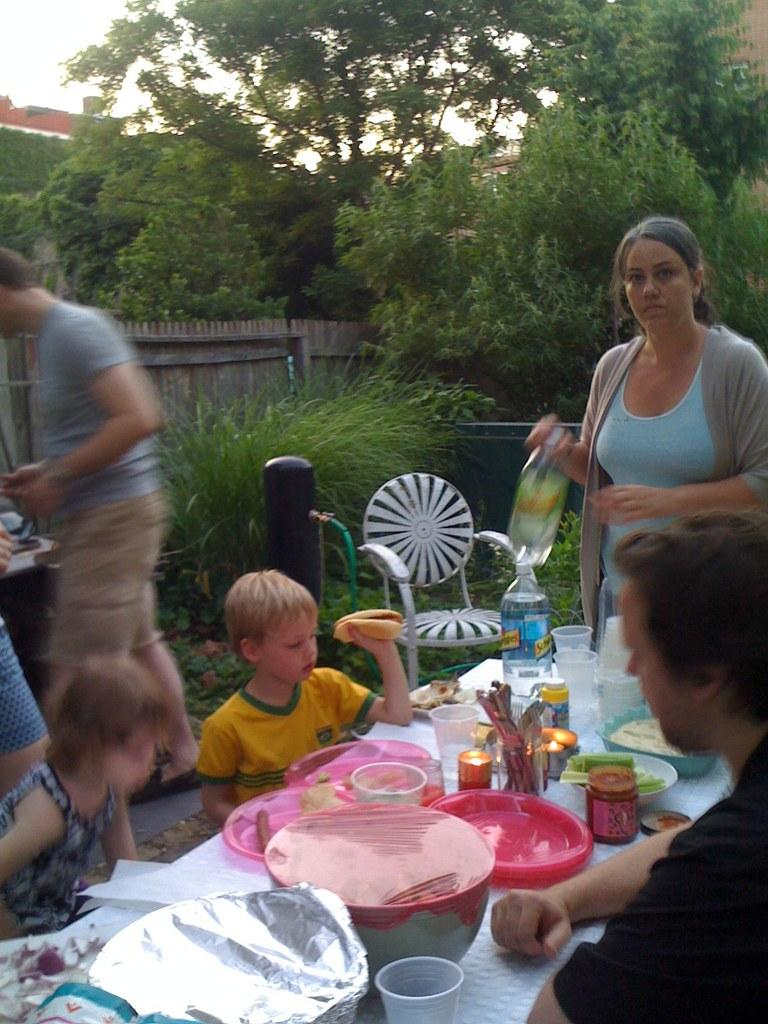What are the people in the image doing? There are people seated on chairs and some people standing in the image. What objects can be seen on the table? There are bowls, plates, bottles, and glasses on the table. What can be seen in the background of the image? There are trees visible in the image. Is there a hose being used to water the trees in the image? There is no hose visible in the image, and the trees do not appear to be receiving water. What type of notebook is being used by the people in the image? There is no notebook present in the image. 